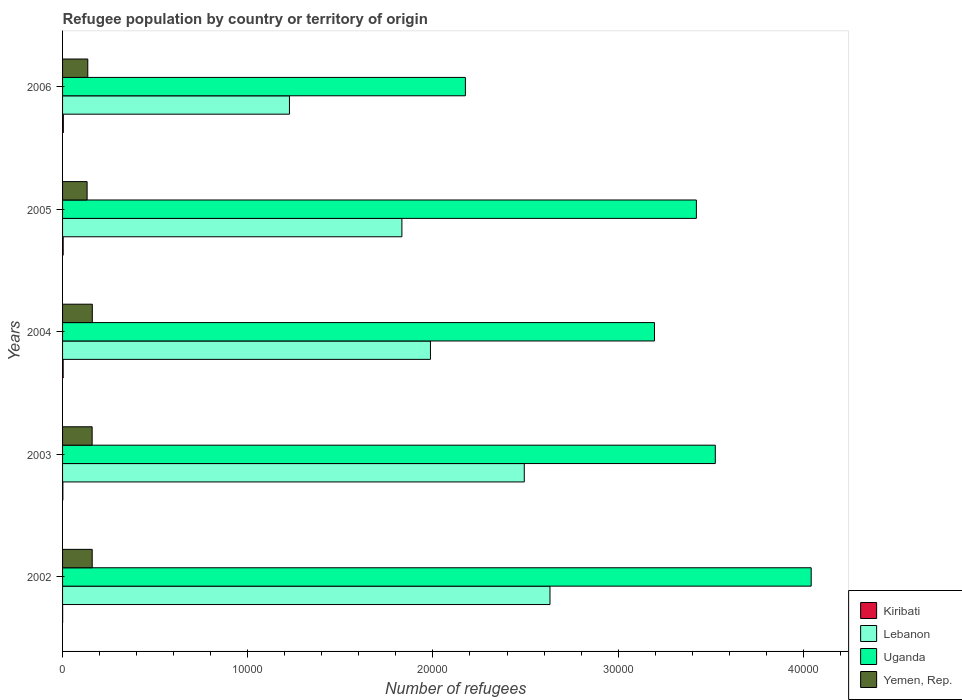How many different coloured bars are there?
Provide a succinct answer. 4. Are the number of bars per tick equal to the number of legend labels?
Offer a very short reply. Yes. Are the number of bars on each tick of the Y-axis equal?
Keep it short and to the point. Yes. How many bars are there on the 2nd tick from the bottom?
Provide a succinct answer. 4. What is the label of the 1st group of bars from the top?
Ensure brevity in your answer.  2006. What is the number of refugees in Yemen, Rep. in 2002?
Provide a short and direct response. 1600. Across all years, what is the minimum number of refugees in Lebanon?
Make the answer very short. 1.23e+04. In which year was the number of refugees in Yemen, Rep. maximum?
Offer a very short reply. 2004. In which year was the number of refugees in Lebanon minimum?
Provide a succinct answer. 2006. What is the total number of refugees in Lebanon in the graph?
Offer a very short reply. 1.02e+05. What is the difference between the number of refugees in Yemen, Rep. in 2002 and that in 2005?
Your answer should be compact. 275. What is the difference between the number of refugees in Kiribati in 2005 and the number of refugees in Yemen, Rep. in 2003?
Offer a very short reply. -1564. What is the average number of refugees in Kiribati per year?
Offer a very short reply. 25. In the year 2005, what is the difference between the number of refugees in Kiribati and number of refugees in Uganda?
Give a very brief answer. -3.42e+04. Is the number of refugees in Yemen, Rep. in 2004 less than that in 2006?
Your answer should be very brief. No. What is the difference between the highest and the second highest number of refugees in Uganda?
Your answer should be very brief. 5178. What is the difference between the highest and the lowest number of refugees in Yemen, Rep.?
Make the answer very short. 281. In how many years, is the number of refugees in Uganda greater than the average number of refugees in Uganda taken over all years?
Provide a short and direct response. 3. Is the sum of the number of refugees in Yemen, Rep. in 2002 and 2004 greater than the maximum number of refugees in Lebanon across all years?
Your response must be concise. No. Is it the case that in every year, the sum of the number of refugees in Uganda and number of refugees in Lebanon is greater than the sum of number of refugees in Kiribati and number of refugees in Yemen, Rep.?
Ensure brevity in your answer.  No. What does the 1st bar from the top in 2003 represents?
Your response must be concise. Yemen, Rep. What does the 2nd bar from the bottom in 2002 represents?
Your answer should be very brief. Lebanon. Are the values on the major ticks of X-axis written in scientific E-notation?
Give a very brief answer. No. Does the graph contain any zero values?
Provide a short and direct response. No. Where does the legend appear in the graph?
Ensure brevity in your answer.  Bottom right. What is the title of the graph?
Give a very brief answer. Refugee population by country or territory of origin. What is the label or title of the X-axis?
Give a very brief answer. Number of refugees. What is the Number of refugees in Lebanon in 2002?
Ensure brevity in your answer.  2.63e+04. What is the Number of refugees in Uganda in 2002?
Offer a very short reply. 4.04e+04. What is the Number of refugees of Yemen, Rep. in 2002?
Your response must be concise. 1600. What is the Number of refugees in Lebanon in 2003?
Your response must be concise. 2.49e+04. What is the Number of refugees in Uganda in 2003?
Your answer should be compact. 3.52e+04. What is the Number of refugees of Yemen, Rep. in 2003?
Your response must be concise. 1597. What is the Number of refugees of Lebanon in 2004?
Your answer should be very brief. 1.99e+04. What is the Number of refugees of Uganda in 2004?
Ensure brevity in your answer.  3.20e+04. What is the Number of refugees in Yemen, Rep. in 2004?
Offer a very short reply. 1606. What is the Number of refugees in Kiribati in 2005?
Your response must be concise. 33. What is the Number of refugees in Lebanon in 2005?
Your answer should be very brief. 1.83e+04. What is the Number of refugees of Uganda in 2005?
Your answer should be very brief. 3.42e+04. What is the Number of refugees of Yemen, Rep. in 2005?
Give a very brief answer. 1325. What is the Number of refugees of Lebanon in 2006?
Provide a short and direct response. 1.23e+04. What is the Number of refugees in Uganda in 2006?
Provide a succinct answer. 2.18e+04. What is the Number of refugees of Yemen, Rep. in 2006?
Keep it short and to the point. 1362. Across all years, what is the maximum Number of refugees of Lebanon?
Your response must be concise. 2.63e+04. Across all years, what is the maximum Number of refugees in Uganda?
Provide a succinct answer. 4.04e+04. Across all years, what is the maximum Number of refugees in Yemen, Rep.?
Provide a short and direct response. 1606. Across all years, what is the minimum Number of refugees in Kiribati?
Keep it short and to the point. 3. Across all years, what is the minimum Number of refugees of Lebanon?
Offer a terse response. 1.23e+04. Across all years, what is the minimum Number of refugees of Uganda?
Your answer should be compact. 2.18e+04. Across all years, what is the minimum Number of refugees in Yemen, Rep.?
Your response must be concise. 1325. What is the total Number of refugees of Kiribati in the graph?
Make the answer very short. 125. What is the total Number of refugees in Lebanon in the graph?
Make the answer very short. 1.02e+05. What is the total Number of refugees of Uganda in the graph?
Make the answer very short. 1.64e+05. What is the total Number of refugees of Yemen, Rep. in the graph?
Make the answer very short. 7490. What is the difference between the Number of refugees in Lebanon in 2002 and that in 2003?
Provide a short and direct response. 1388. What is the difference between the Number of refugees of Uganda in 2002 and that in 2003?
Your response must be concise. 5178. What is the difference between the Number of refugees in Yemen, Rep. in 2002 and that in 2003?
Your answer should be compact. 3. What is the difference between the Number of refugees of Lebanon in 2002 and that in 2004?
Your answer should be compact. 6454. What is the difference between the Number of refugees of Uganda in 2002 and that in 2004?
Ensure brevity in your answer.  8462. What is the difference between the Number of refugees in Yemen, Rep. in 2002 and that in 2004?
Make the answer very short. -6. What is the difference between the Number of refugees of Lebanon in 2002 and that in 2005?
Give a very brief answer. 7997. What is the difference between the Number of refugees of Uganda in 2002 and that in 2005?
Give a very brief answer. 6200. What is the difference between the Number of refugees in Yemen, Rep. in 2002 and that in 2005?
Offer a terse response. 275. What is the difference between the Number of refugees in Kiribati in 2002 and that in 2006?
Make the answer very short. -38. What is the difference between the Number of refugees in Lebanon in 2002 and that in 2006?
Offer a terse response. 1.41e+04. What is the difference between the Number of refugees in Uganda in 2002 and that in 2006?
Provide a short and direct response. 1.87e+04. What is the difference between the Number of refugees of Yemen, Rep. in 2002 and that in 2006?
Your answer should be compact. 238. What is the difference between the Number of refugees in Lebanon in 2003 and that in 2004?
Offer a terse response. 5066. What is the difference between the Number of refugees of Uganda in 2003 and that in 2004?
Make the answer very short. 3284. What is the difference between the Number of refugees in Yemen, Rep. in 2003 and that in 2004?
Make the answer very short. -9. What is the difference between the Number of refugees of Lebanon in 2003 and that in 2005?
Ensure brevity in your answer.  6609. What is the difference between the Number of refugees in Uganda in 2003 and that in 2005?
Your response must be concise. 1022. What is the difference between the Number of refugees in Yemen, Rep. in 2003 and that in 2005?
Provide a short and direct response. 272. What is the difference between the Number of refugees of Kiribati in 2003 and that in 2006?
Make the answer very short. -25. What is the difference between the Number of refugees of Lebanon in 2003 and that in 2006?
Offer a very short reply. 1.27e+04. What is the difference between the Number of refugees of Uganda in 2003 and that in 2006?
Provide a succinct answer. 1.35e+04. What is the difference between the Number of refugees in Yemen, Rep. in 2003 and that in 2006?
Provide a short and direct response. 235. What is the difference between the Number of refugees in Lebanon in 2004 and that in 2005?
Make the answer very short. 1543. What is the difference between the Number of refugees in Uganda in 2004 and that in 2005?
Give a very brief answer. -2262. What is the difference between the Number of refugees in Yemen, Rep. in 2004 and that in 2005?
Keep it short and to the point. 281. What is the difference between the Number of refugees of Kiribati in 2004 and that in 2006?
Ensure brevity in your answer.  -9. What is the difference between the Number of refugees of Lebanon in 2004 and that in 2006?
Your response must be concise. 7614. What is the difference between the Number of refugees of Uganda in 2004 and that in 2006?
Your answer should be compact. 1.02e+04. What is the difference between the Number of refugees in Yemen, Rep. in 2004 and that in 2006?
Your response must be concise. 244. What is the difference between the Number of refugees in Lebanon in 2005 and that in 2006?
Your answer should be very brief. 6071. What is the difference between the Number of refugees of Uganda in 2005 and that in 2006?
Give a very brief answer. 1.25e+04. What is the difference between the Number of refugees in Yemen, Rep. in 2005 and that in 2006?
Keep it short and to the point. -37. What is the difference between the Number of refugees in Kiribati in 2002 and the Number of refugees in Lebanon in 2003?
Give a very brief answer. -2.49e+04. What is the difference between the Number of refugees in Kiribati in 2002 and the Number of refugees in Uganda in 2003?
Give a very brief answer. -3.52e+04. What is the difference between the Number of refugees in Kiribati in 2002 and the Number of refugees in Yemen, Rep. in 2003?
Your answer should be compact. -1594. What is the difference between the Number of refugees of Lebanon in 2002 and the Number of refugees of Uganda in 2003?
Your answer should be compact. -8927. What is the difference between the Number of refugees of Lebanon in 2002 and the Number of refugees of Yemen, Rep. in 2003?
Offer a very short reply. 2.47e+04. What is the difference between the Number of refugees in Uganda in 2002 and the Number of refugees in Yemen, Rep. in 2003?
Offer a very short reply. 3.88e+04. What is the difference between the Number of refugees in Kiribati in 2002 and the Number of refugees in Lebanon in 2004?
Provide a short and direct response. -1.99e+04. What is the difference between the Number of refugees in Kiribati in 2002 and the Number of refugees in Uganda in 2004?
Give a very brief answer. -3.20e+04. What is the difference between the Number of refugees of Kiribati in 2002 and the Number of refugees of Yemen, Rep. in 2004?
Make the answer very short. -1603. What is the difference between the Number of refugees of Lebanon in 2002 and the Number of refugees of Uganda in 2004?
Keep it short and to the point. -5643. What is the difference between the Number of refugees of Lebanon in 2002 and the Number of refugees of Yemen, Rep. in 2004?
Make the answer very short. 2.47e+04. What is the difference between the Number of refugees of Uganda in 2002 and the Number of refugees of Yemen, Rep. in 2004?
Your response must be concise. 3.88e+04. What is the difference between the Number of refugees in Kiribati in 2002 and the Number of refugees in Lebanon in 2005?
Ensure brevity in your answer.  -1.83e+04. What is the difference between the Number of refugees of Kiribati in 2002 and the Number of refugees of Uganda in 2005?
Give a very brief answer. -3.42e+04. What is the difference between the Number of refugees of Kiribati in 2002 and the Number of refugees of Yemen, Rep. in 2005?
Provide a succinct answer. -1322. What is the difference between the Number of refugees of Lebanon in 2002 and the Number of refugees of Uganda in 2005?
Provide a short and direct response. -7905. What is the difference between the Number of refugees of Lebanon in 2002 and the Number of refugees of Yemen, Rep. in 2005?
Your answer should be compact. 2.50e+04. What is the difference between the Number of refugees in Uganda in 2002 and the Number of refugees in Yemen, Rep. in 2005?
Provide a succinct answer. 3.91e+04. What is the difference between the Number of refugees in Kiribati in 2002 and the Number of refugees in Lebanon in 2006?
Provide a short and direct response. -1.22e+04. What is the difference between the Number of refugees in Kiribati in 2002 and the Number of refugees in Uganda in 2006?
Offer a very short reply. -2.17e+04. What is the difference between the Number of refugees of Kiribati in 2002 and the Number of refugees of Yemen, Rep. in 2006?
Offer a terse response. -1359. What is the difference between the Number of refugees of Lebanon in 2002 and the Number of refugees of Uganda in 2006?
Give a very brief answer. 4568. What is the difference between the Number of refugees of Lebanon in 2002 and the Number of refugees of Yemen, Rep. in 2006?
Give a very brief answer. 2.50e+04. What is the difference between the Number of refugees of Uganda in 2002 and the Number of refugees of Yemen, Rep. in 2006?
Ensure brevity in your answer.  3.91e+04. What is the difference between the Number of refugees of Kiribati in 2003 and the Number of refugees of Lebanon in 2004?
Give a very brief answer. -1.98e+04. What is the difference between the Number of refugees in Kiribati in 2003 and the Number of refugees in Uganda in 2004?
Provide a short and direct response. -3.19e+04. What is the difference between the Number of refugees in Kiribati in 2003 and the Number of refugees in Yemen, Rep. in 2004?
Your answer should be very brief. -1590. What is the difference between the Number of refugees in Lebanon in 2003 and the Number of refugees in Uganda in 2004?
Provide a succinct answer. -7031. What is the difference between the Number of refugees of Lebanon in 2003 and the Number of refugees of Yemen, Rep. in 2004?
Keep it short and to the point. 2.33e+04. What is the difference between the Number of refugees of Uganda in 2003 and the Number of refugees of Yemen, Rep. in 2004?
Keep it short and to the point. 3.36e+04. What is the difference between the Number of refugees of Kiribati in 2003 and the Number of refugees of Lebanon in 2005?
Give a very brief answer. -1.83e+04. What is the difference between the Number of refugees in Kiribati in 2003 and the Number of refugees in Uganda in 2005?
Offer a very short reply. -3.42e+04. What is the difference between the Number of refugees in Kiribati in 2003 and the Number of refugees in Yemen, Rep. in 2005?
Provide a short and direct response. -1309. What is the difference between the Number of refugees of Lebanon in 2003 and the Number of refugees of Uganda in 2005?
Provide a succinct answer. -9293. What is the difference between the Number of refugees of Lebanon in 2003 and the Number of refugees of Yemen, Rep. in 2005?
Give a very brief answer. 2.36e+04. What is the difference between the Number of refugees of Uganda in 2003 and the Number of refugees of Yemen, Rep. in 2005?
Offer a terse response. 3.39e+04. What is the difference between the Number of refugees in Kiribati in 2003 and the Number of refugees in Lebanon in 2006?
Make the answer very short. -1.22e+04. What is the difference between the Number of refugees in Kiribati in 2003 and the Number of refugees in Uganda in 2006?
Offer a terse response. -2.17e+04. What is the difference between the Number of refugees of Kiribati in 2003 and the Number of refugees of Yemen, Rep. in 2006?
Keep it short and to the point. -1346. What is the difference between the Number of refugees in Lebanon in 2003 and the Number of refugees in Uganda in 2006?
Give a very brief answer. 3180. What is the difference between the Number of refugees in Lebanon in 2003 and the Number of refugees in Yemen, Rep. in 2006?
Offer a very short reply. 2.36e+04. What is the difference between the Number of refugees of Uganda in 2003 and the Number of refugees of Yemen, Rep. in 2006?
Provide a succinct answer. 3.39e+04. What is the difference between the Number of refugees in Kiribati in 2004 and the Number of refugees in Lebanon in 2005?
Keep it short and to the point. -1.83e+04. What is the difference between the Number of refugees of Kiribati in 2004 and the Number of refugees of Uganda in 2005?
Provide a succinct answer. -3.42e+04. What is the difference between the Number of refugees of Kiribati in 2004 and the Number of refugees of Yemen, Rep. in 2005?
Provide a succinct answer. -1293. What is the difference between the Number of refugees in Lebanon in 2004 and the Number of refugees in Uganda in 2005?
Provide a succinct answer. -1.44e+04. What is the difference between the Number of refugees in Lebanon in 2004 and the Number of refugees in Yemen, Rep. in 2005?
Your answer should be very brief. 1.85e+04. What is the difference between the Number of refugees in Uganda in 2004 and the Number of refugees in Yemen, Rep. in 2005?
Offer a very short reply. 3.06e+04. What is the difference between the Number of refugees in Kiribati in 2004 and the Number of refugees in Lebanon in 2006?
Your response must be concise. -1.22e+04. What is the difference between the Number of refugees in Kiribati in 2004 and the Number of refugees in Uganda in 2006?
Keep it short and to the point. -2.17e+04. What is the difference between the Number of refugees of Kiribati in 2004 and the Number of refugees of Yemen, Rep. in 2006?
Offer a very short reply. -1330. What is the difference between the Number of refugees in Lebanon in 2004 and the Number of refugees in Uganda in 2006?
Make the answer very short. -1886. What is the difference between the Number of refugees in Lebanon in 2004 and the Number of refugees in Yemen, Rep. in 2006?
Give a very brief answer. 1.85e+04. What is the difference between the Number of refugees of Uganda in 2004 and the Number of refugees of Yemen, Rep. in 2006?
Your answer should be very brief. 3.06e+04. What is the difference between the Number of refugees in Kiribati in 2005 and the Number of refugees in Lebanon in 2006?
Your answer should be compact. -1.22e+04. What is the difference between the Number of refugees of Kiribati in 2005 and the Number of refugees of Uganda in 2006?
Your response must be concise. -2.17e+04. What is the difference between the Number of refugees of Kiribati in 2005 and the Number of refugees of Yemen, Rep. in 2006?
Offer a very short reply. -1329. What is the difference between the Number of refugees in Lebanon in 2005 and the Number of refugees in Uganda in 2006?
Give a very brief answer. -3429. What is the difference between the Number of refugees in Lebanon in 2005 and the Number of refugees in Yemen, Rep. in 2006?
Your answer should be compact. 1.70e+04. What is the difference between the Number of refugees in Uganda in 2005 and the Number of refugees in Yemen, Rep. in 2006?
Your answer should be very brief. 3.29e+04. What is the average Number of refugees of Lebanon per year?
Ensure brevity in your answer.  2.03e+04. What is the average Number of refugees in Uganda per year?
Your response must be concise. 3.27e+04. What is the average Number of refugees of Yemen, Rep. per year?
Keep it short and to the point. 1498. In the year 2002, what is the difference between the Number of refugees of Kiribati and Number of refugees of Lebanon?
Your answer should be compact. -2.63e+04. In the year 2002, what is the difference between the Number of refugees in Kiribati and Number of refugees in Uganda?
Offer a terse response. -4.04e+04. In the year 2002, what is the difference between the Number of refugees of Kiribati and Number of refugees of Yemen, Rep.?
Your response must be concise. -1597. In the year 2002, what is the difference between the Number of refugees in Lebanon and Number of refugees in Uganda?
Provide a succinct answer. -1.41e+04. In the year 2002, what is the difference between the Number of refugees in Lebanon and Number of refugees in Yemen, Rep.?
Make the answer very short. 2.47e+04. In the year 2002, what is the difference between the Number of refugees of Uganda and Number of refugees of Yemen, Rep.?
Provide a succinct answer. 3.88e+04. In the year 2003, what is the difference between the Number of refugees in Kiribati and Number of refugees in Lebanon?
Keep it short and to the point. -2.49e+04. In the year 2003, what is the difference between the Number of refugees of Kiribati and Number of refugees of Uganda?
Your answer should be compact. -3.52e+04. In the year 2003, what is the difference between the Number of refugees in Kiribati and Number of refugees in Yemen, Rep.?
Ensure brevity in your answer.  -1581. In the year 2003, what is the difference between the Number of refugees in Lebanon and Number of refugees in Uganda?
Offer a terse response. -1.03e+04. In the year 2003, what is the difference between the Number of refugees of Lebanon and Number of refugees of Yemen, Rep.?
Provide a short and direct response. 2.33e+04. In the year 2003, what is the difference between the Number of refugees in Uganda and Number of refugees in Yemen, Rep.?
Offer a very short reply. 3.36e+04. In the year 2004, what is the difference between the Number of refugees in Kiribati and Number of refugees in Lebanon?
Provide a short and direct response. -1.98e+04. In the year 2004, what is the difference between the Number of refugees of Kiribati and Number of refugees of Uganda?
Make the answer very short. -3.19e+04. In the year 2004, what is the difference between the Number of refugees in Kiribati and Number of refugees in Yemen, Rep.?
Make the answer very short. -1574. In the year 2004, what is the difference between the Number of refugees in Lebanon and Number of refugees in Uganda?
Your response must be concise. -1.21e+04. In the year 2004, what is the difference between the Number of refugees of Lebanon and Number of refugees of Yemen, Rep.?
Provide a short and direct response. 1.83e+04. In the year 2004, what is the difference between the Number of refugees of Uganda and Number of refugees of Yemen, Rep.?
Provide a short and direct response. 3.04e+04. In the year 2005, what is the difference between the Number of refugees of Kiribati and Number of refugees of Lebanon?
Keep it short and to the point. -1.83e+04. In the year 2005, what is the difference between the Number of refugees of Kiribati and Number of refugees of Uganda?
Give a very brief answer. -3.42e+04. In the year 2005, what is the difference between the Number of refugees of Kiribati and Number of refugees of Yemen, Rep.?
Offer a terse response. -1292. In the year 2005, what is the difference between the Number of refugees of Lebanon and Number of refugees of Uganda?
Your response must be concise. -1.59e+04. In the year 2005, what is the difference between the Number of refugees of Lebanon and Number of refugees of Yemen, Rep.?
Provide a succinct answer. 1.70e+04. In the year 2005, what is the difference between the Number of refugees of Uganda and Number of refugees of Yemen, Rep.?
Keep it short and to the point. 3.29e+04. In the year 2006, what is the difference between the Number of refugees in Kiribati and Number of refugees in Lebanon?
Offer a terse response. -1.22e+04. In the year 2006, what is the difference between the Number of refugees of Kiribati and Number of refugees of Uganda?
Ensure brevity in your answer.  -2.17e+04. In the year 2006, what is the difference between the Number of refugees in Kiribati and Number of refugees in Yemen, Rep.?
Ensure brevity in your answer.  -1321. In the year 2006, what is the difference between the Number of refugees of Lebanon and Number of refugees of Uganda?
Provide a short and direct response. -9500. In the year 2006, what is the difference between the Number of refugees in Lebanon and Number of refugees in Yemen, Rep.?
Your response must be concise. 1.09e+04. In the year 2006, what is the difference between the Number of refugees of Uganda and Number of refugees of Yemen, Rep.?
Provide a succinct answer. 2.04e+04. What is the ratio of the Number of refugees in Kiribati in 2002 to that in 2003?
Offer a terse response. 0.19. What is the ratio of the Number of refugees in Lebanon in 2002 to that in 2003?
Give a very brief answer. 1.06. What is the ratio of the Number of refugees of Uganda in 2002 to that in 2003?
Offer a terse response. 1.15. What is the ratio of the Number of refugees in Kiribati in 2002 to that in 2004?
Ensure brevity in your answer.  0.09. What is the ratio of the Number of refugees in Lebanon in 2002 to that in 2004?
Give a very brief answer. 1.32. What is the ratio of the Number of refugees in Uganda in 2002 to that in 2004?
Offer a very short reply. 1.26. What is the ratio of the Number of refugees of Kiribati in 2002 to that in 2005?
Offer a terse response. 0.09. What is the ratio of the Number of refugees of Lebanon in 2002 to that in 2005?
Offer a very short reply. 1.44. What is the ratio of the Number of refugees of Uganda in 2002 to that in 2005?
Your response must be concise. 1.18. What is the ratio of the Number of refugees of Yemen, Rep. in 2002 to that in 2005?
Provide a short and direct response. 1.21. What is the ratio of the Number of refugees in Kiribati in 2002 to that in 2006?
Your answer should be very brief. 0.07. What is the ratio of the Number of refugees in Lebanon in 2002 to that in 2006?
Your answer should be compact. 2.15. What is the ratio of the Number of refugees in Uganda in 2002 to that in 2006?
Provide a short and direct response. 1.86. What is the ratio of the Number of refugees in Yemen, Rep. in 2002 to that in 2006?
Give a very brief answer. 1.17. What is the ratio of the Number of refugees of Lebanon in 2003 to that in 2004?
Ensure brevity in your answer.  1.25. What is the ratio of the Number of refugees of Uganda in 2003 to that in 2004?
Make the answer very short. 1.1. What is the ratio of the Number of refugees of Kiribati in 2003 to that in 2005?
Your answer should be very brief. 0.48. What is the ratio of the Number of refugees of Lebanon in 2003 to that in 2005?
Offer a very short reply. 1.36. What is the ratio of the Number of refugees of Uganda in 2003 to that in 2005?
Offer a terse response. 1.03. What is the ratio of the Number of refugees in Yemen, Rep. in 2003 to that in 2005?
Make the answer very short. 1.21. What is the ratio of the Number of refugees in Kiribati in 2003 to that in 2006?
Provide a short and direct response. 0.39. What is the ratio of the Number of refugees in Lebanon in 2003 to that in 2006?
Offer a very short reply. 2.03. What is the ratio of the Number of refugees of Uganda in 2003 to that in 2006?
Make the answer very short. 1.62. What is the ratio of the Number of refugees in Yemen, Rep. in 2003 to that in 2006?
Provide a succinct answer. 1.17. What is the ratio of the Number of refugees in Kiribati in 2004 to that in 2005?
Make the answer very short. 0.97. What is the ratio of the Number of refugees in Lebanon in 2004 to that in 2005?
Your response must be concise. 1.08. What is the ratio of the Number of refugees in Uganda in 2004 to that in 2005?
Offer a very short reply. 0.93. What is the ratio of the Number of refugees in Yemen, Rep. in 2004 to that in 2005?
Keep it short and to the point. 1.21. What is the ratio of the Number of refugees in Kiribati in 2004 to that in 2006?
Ensure brevity in your answer.  0.78. What is the ratio of the Number of refugees in Lebanon in 2004 to that in 2006?
Your response must be concise. 1.62. What is the ratio of the Number of refugees of Uganda in 2004 to that in 2006?
Your answer should be very brief. 1.47. What is the ratio of the Number of refugees in Yemen, Rep. in 2004 to that in 2006?
Ensure brevity in your answer.  1.18. What is the ratio of the Number of refugees of Kiribati in 2005 to that in 2006?
Your response must be concise. 0.8. What is the ratio of the Number of refugees of Lebanon in 2005 to that in 2006?
Offer a very short reply. 1.5. What is the ratio of the Number of refugees of Uganda in 2005 to that in 2006?
Provide a short and direct response. 1.57. What is the ratio of the Number of refugees of Yemen, Rep. in 2005 to that in 2006?
Offer a terse response. 0.97. What is the difference between the highest and the second highest Number of refugees of Kiribati?
Your response must be concise. 8. What is the difference between the highest and the second highest Number of refugees in Lebanon?
Make the answer very short. 1388. What is the difference between the highest and the second highest Number of refugees of Uganda?
Your answer should be compact. 5178. What is the difference between the highest and the second highest Number of refugees in Yemen, Rep.?
Provide a short and direct response. 6. What is the difference between the highest and the lowest Number of refugees in Lebanon?
Provide a succinct answer. 1.41e+04. What is the difference between the highest and the lowest Number of refugees of Uganda?
Your response must be concise. 1.87e+04. What is the difference between the highest and the lowest Number of refugees in Yemen, Rep.?
Give a very brief answer. 281. 